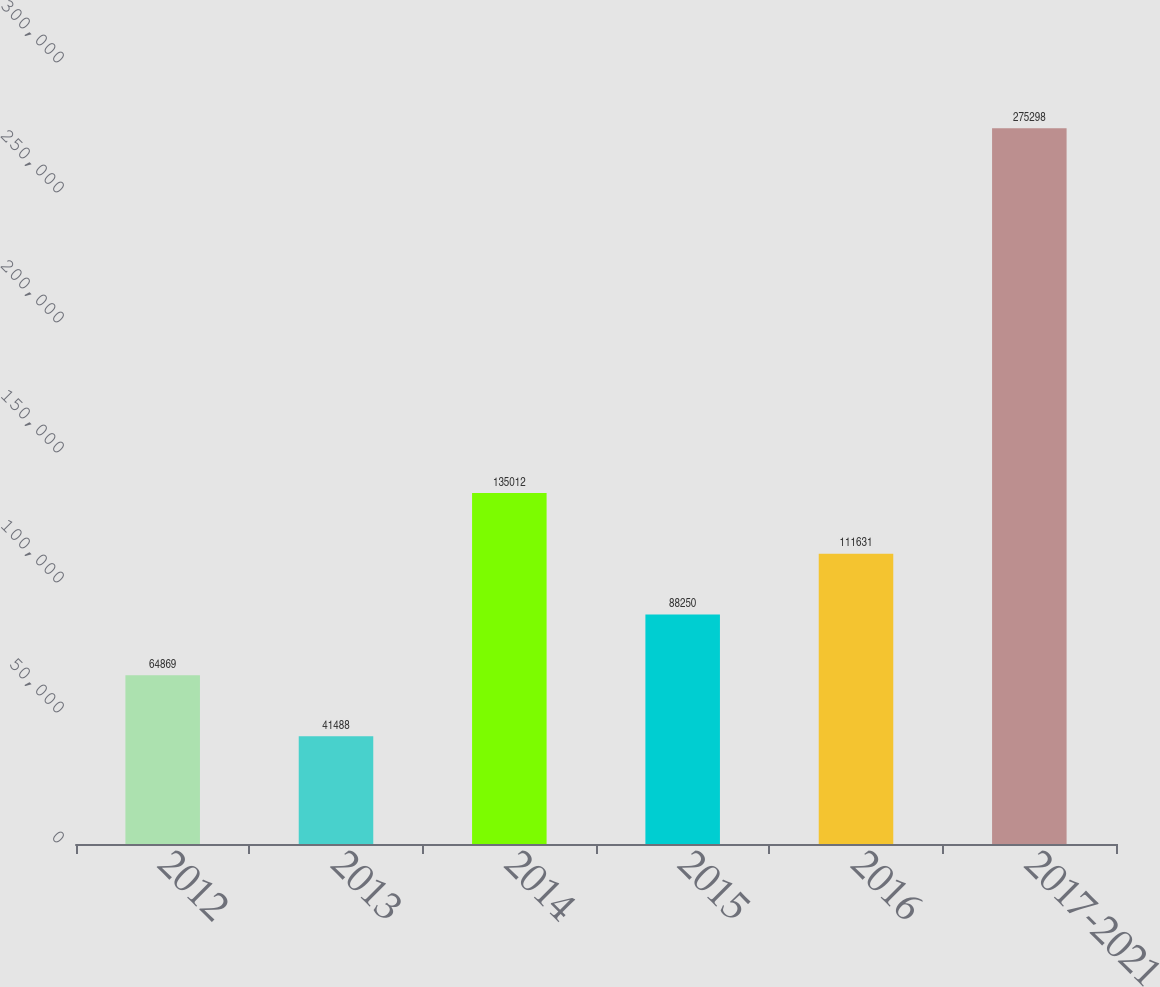<chart> <loc_0><loc_0><loc_500><loc_500><bar_chart><fcel>2012<fcel>2013<fcel>2014<fcel>2015<fcel>2016<fcel>2017-2021<nl><fcel>64869<fcel>41488<fcel>135012<fcel>88250<fcel>111631<fcel>275298<nl></chart> 